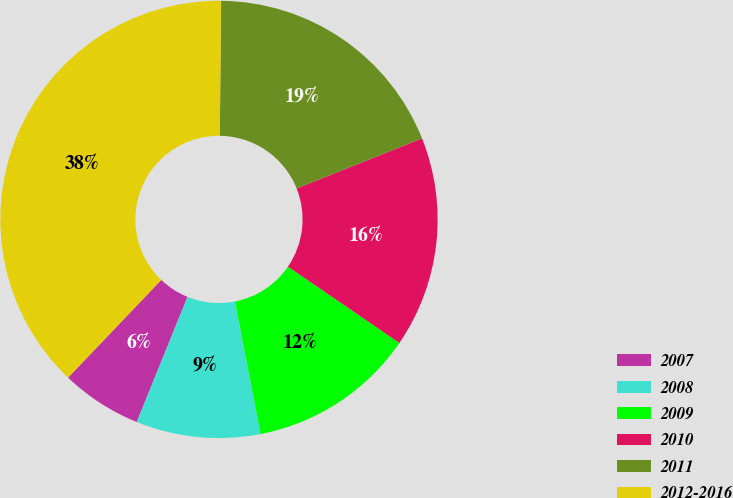<chart> <loc_0><loc_0><loc_500><loc_500><pie_chart><fcel>2007<fcel>2008<fcel>2009<fcel>2010<fcel>2011<fcel>2012-2016<nl><fcel>5.99%<fcel>9.19%<fcel>12.39%<fcel>15.6%<fcel>18.8%<fcel>38.03%<nl></chart> 